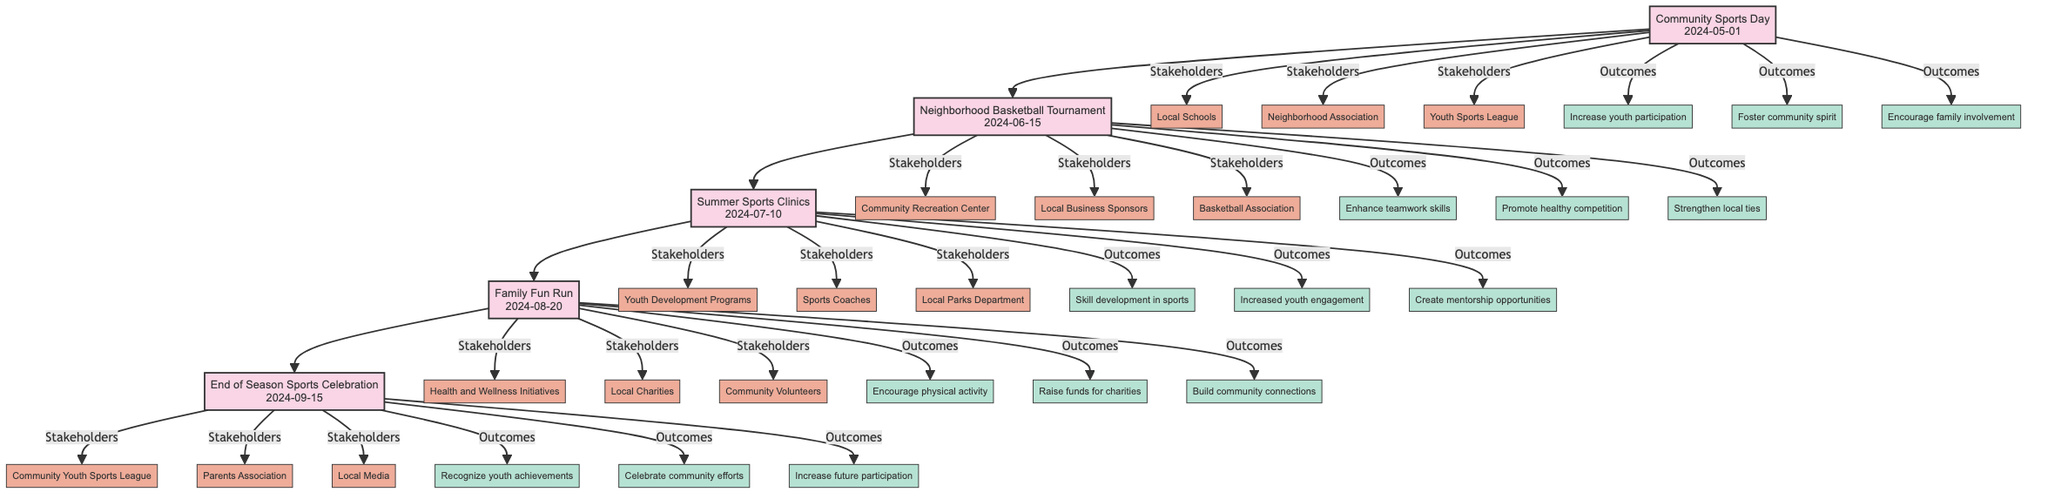What's the first event in the timeline? The first event listed in the diagram is "Community Sports Day" on May 1, 2024, which is positioned at the start of the directed graph.
Answer: Community Sports Day How many stakeholders are involved in the Family Fun Run? The diagram indicates that there are three stakeholders associated with the Family Fun Run event, specifically "Health and Wellness Initiatives," "Local Charities," and "Community Volunteers."
Answer: 3 What is the date of the Neighborhood Basketball Tournament? The diagram explicitly states that the Neighborhood Basketball Tournament is scheduled for June 15, 2024, which is connected to the event node.
Answer: 2024-06-15 Which event follows Summer Sports Clinics in the timeline? The directed graph shows that the event following the Summer Sports Clinics is the Family Fun Run, illustrated by the directed edge pointing from the Summer Sports Clinics node to the Family Fun Run node.
Answer: Family Fun Run What outcome is associated with the End of Season Sports Celebration? The diagram includes "Recognize youth achievements" as one of the outcomes linked to the End of Season Sports Celebration event, clearly shown connecting to that event node.
Answer: Recognize youth achievements Which stakeholders are involved in the Community Sports Day? The Community Sports Day lists three stakeholders: "Local Schools," "Neighborhood Association," and "Youth Sports League." Each stakeholder is directly associated with the Community Sports Day event node, illustrating their involvement.
Answer: Local Schools, Neighborhood Association, Youth Sports League What is the last event scheduled in the timeline? The last event in the directed graph is the End of Season Sports Celebration, which is the last node depicted in the sequential flow of events.
Answer: End of Season Sports Celebration How does the Neighborhood Basketball Tournament contribute to strengthening community ties? The outcomes linked to the Neighborhood Basketball Tournament include "Strengthen local ties," indicating that the event is designed to enhance connections within the community. This conclusion is drawn from the direct association of the outcome node to the event node.
Answer: Strengthen local ties Which event increases youth engagement as an outcome? The Summer Sports Clinics specifically lists "Increased youth engagement" among its outcomes, indicating a direct focus on promoting youth participation in sports. This is evident from the connections drawn to the outcome nodes in the diagram.
Answer: Increased youth engagement 